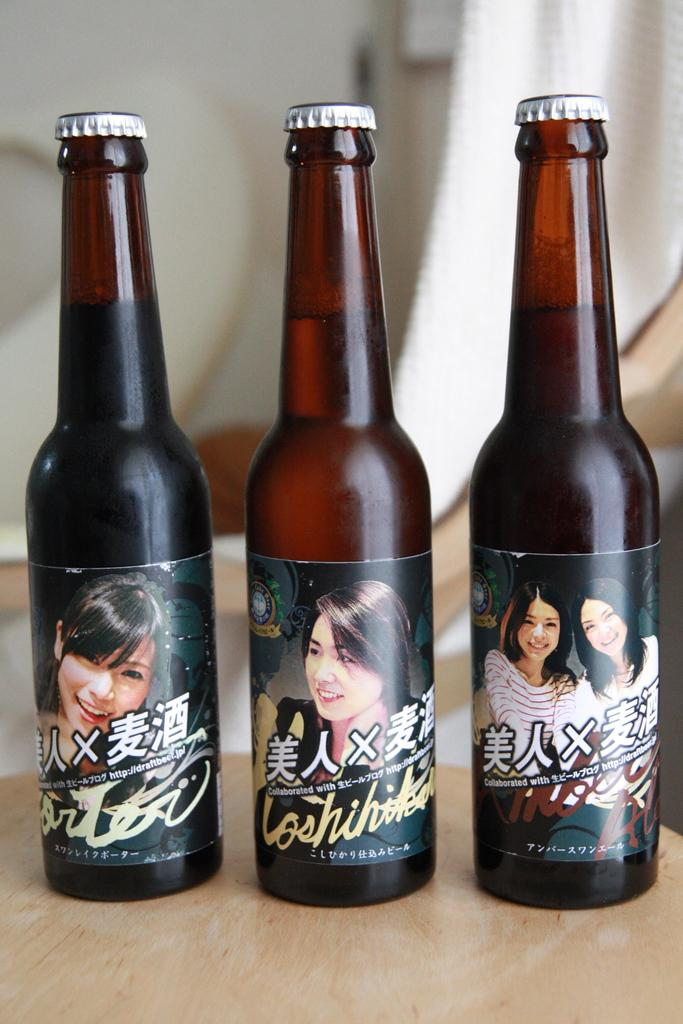How many bottles are visible in the image? There are three bottles in the image. Where are the bottles located? The bottles are on a table. What type of punishment is being administered to the head in the image? There is no head or punishment present in the image; it only features three bottles on a table. 